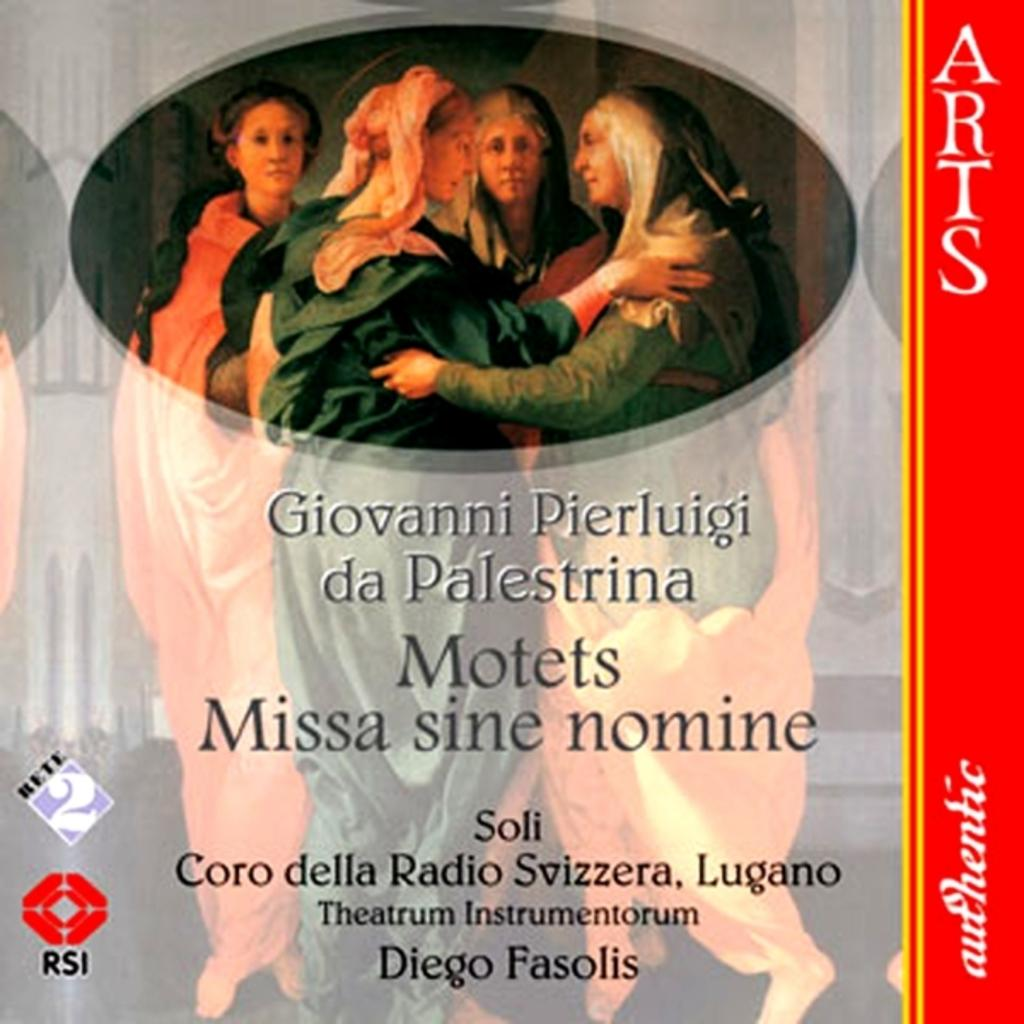<image>
Offer a succinct explanation of the picture presented. Cover for "Giovanni Pierluigi da Palestrina" showing four women on the cover. 